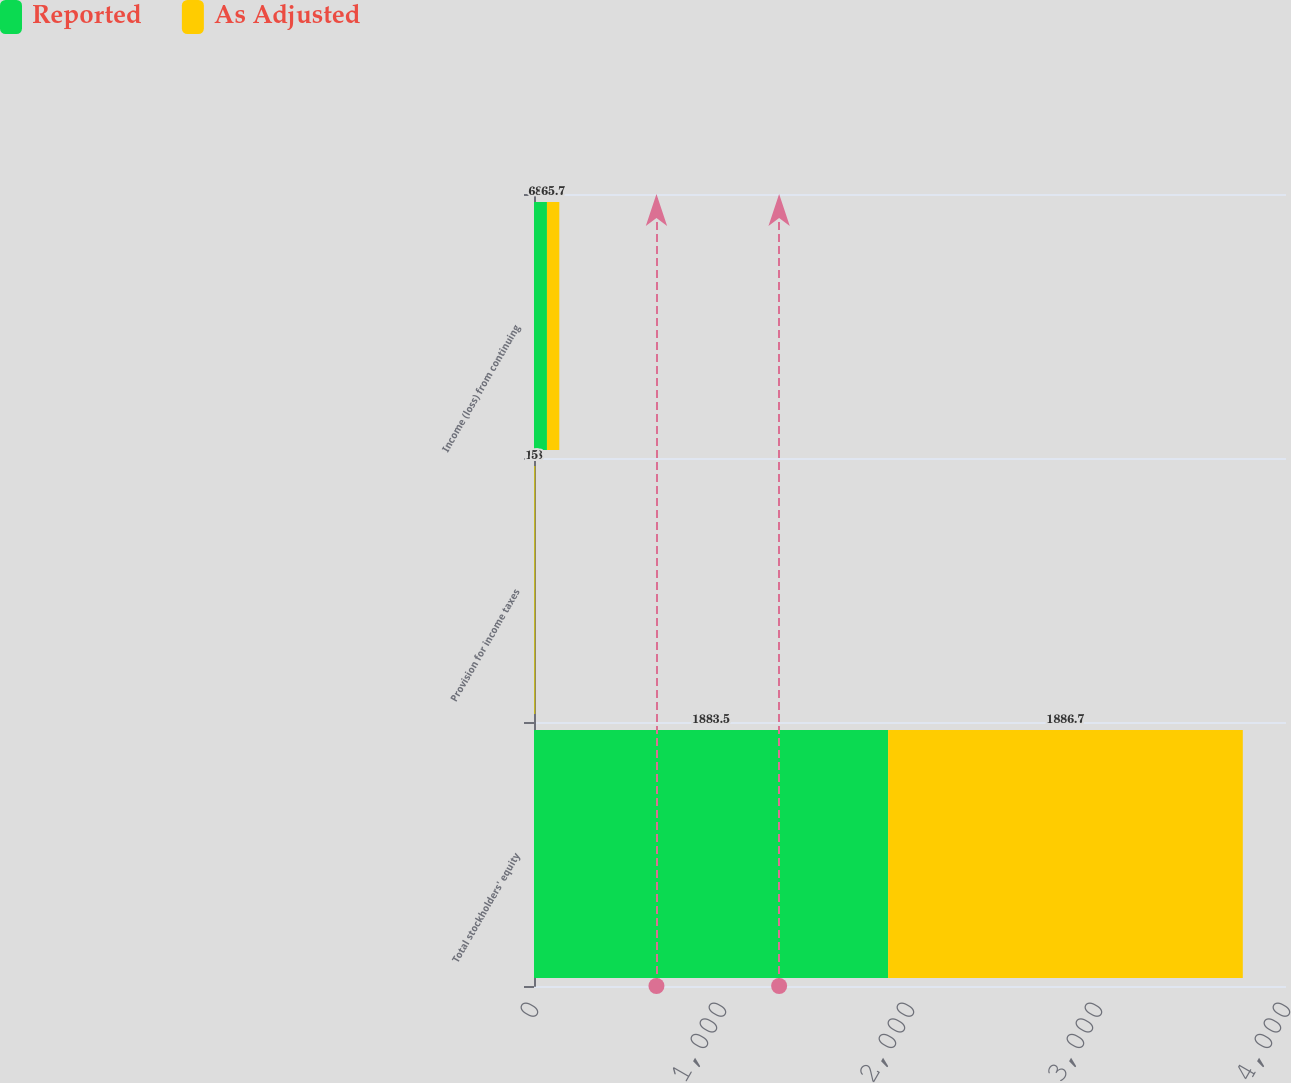<chart> <loc_0><loc_0><loc_500><loc_500><stacked_bar_chart><ecel><fcel>Total stockholders' equity<fcel>Provision for income taxes<fcel>Income (loss) from continuing<nl><fcel>Reported<fcel>1883.5<fcel>1.8<fcel>68.9<nl><fcel>As Adjusted<fcel>1886.7<fcel>5<fcel>65.7<nl></chart> 